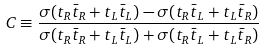<formula> <loc_0><loc_0><loc_500><loc_500>C \equiv \frac { \sigma ( t _ { R } \bar { t } _ { R } + t _ { L } \bar { t } _ { L } ) - \sigma ( t _ { R } \bar { t } _ { L } + t _ { L } \bar { t } _ { R } ) } { \sigma ( t _ { R } \bar { t } _ { R } + t _ { L } \bar { t } _ { L } ) + \sigma ( t _ { R } \bar { t } _ { L } + t _ { L } \bar { t } _ { R } ) }</formula> 